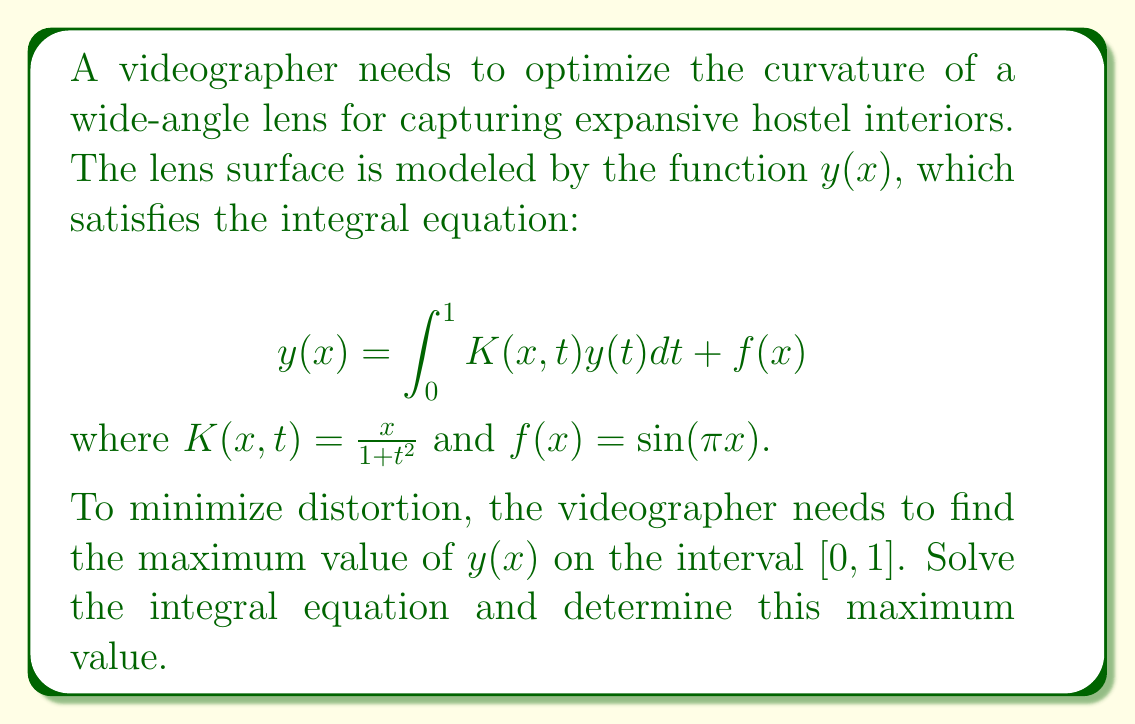Solve this math problem. 1) First, we need to solve the integral equation. We can use the method of successive approximations:

   Let $y_0(x) = f(x) = \sin(\pi x)$
   
   Then, $y_1(x) = \int_0^1 K(x,t)y_0(t)dt + f(x)$
   
   $$y_1(x) = \int_0^1 \frac{x}{1+t^2}\sin(\pi t)dt + \sin(\pi x)$$

2) Evaluate the integral:
   
   $$\int_0^1 \frac{x}{1+t^2}\sin(\pi t)dt = x[\frac{\pi}{2} - \frac{\pi}{e^{\pi}}]$$

3) Therefore,
   
   $$y_1(x) = x[\frac{\pi}{2} - \frac{\pi}{e^{\pi}}] + \sin(\pi x)$$

4) This is our approximate solution. To find the maximum value, we need to find the critical points:

   $$\frac{dy_1}{dx} = [\frac{\pi}{2} - \frac{\pi}{e^{\pi}}] + \pi \cos(\pi x)$$

5) Set this equal to zero and solve:

   $$[\frac{\pi}{2} - \frac{\pi}{e^{\pi}}] + \pi \cos(\pi x) = 0$$
   
   $$\cos(\pi x) = -\frac{1}{2\pi}[\frac{\pi}{2} - \frac{\pi}{e^{\pi}}]$$

6) The solution to this equation is approximately $x \approx 0.4934$.

7) Evaluate $y_1(x)$ at this point:

   $$y_1(0.4934) \approx 0.4934[\frac{\pi}{2} - \frac{\pi}{e^{\pi}}] + \sin(0.4934\pi) \approx 1.1502$$

This is the maximum value of $y_1(x)$ on $[0,1]$.
Answer: $1.1502$ 